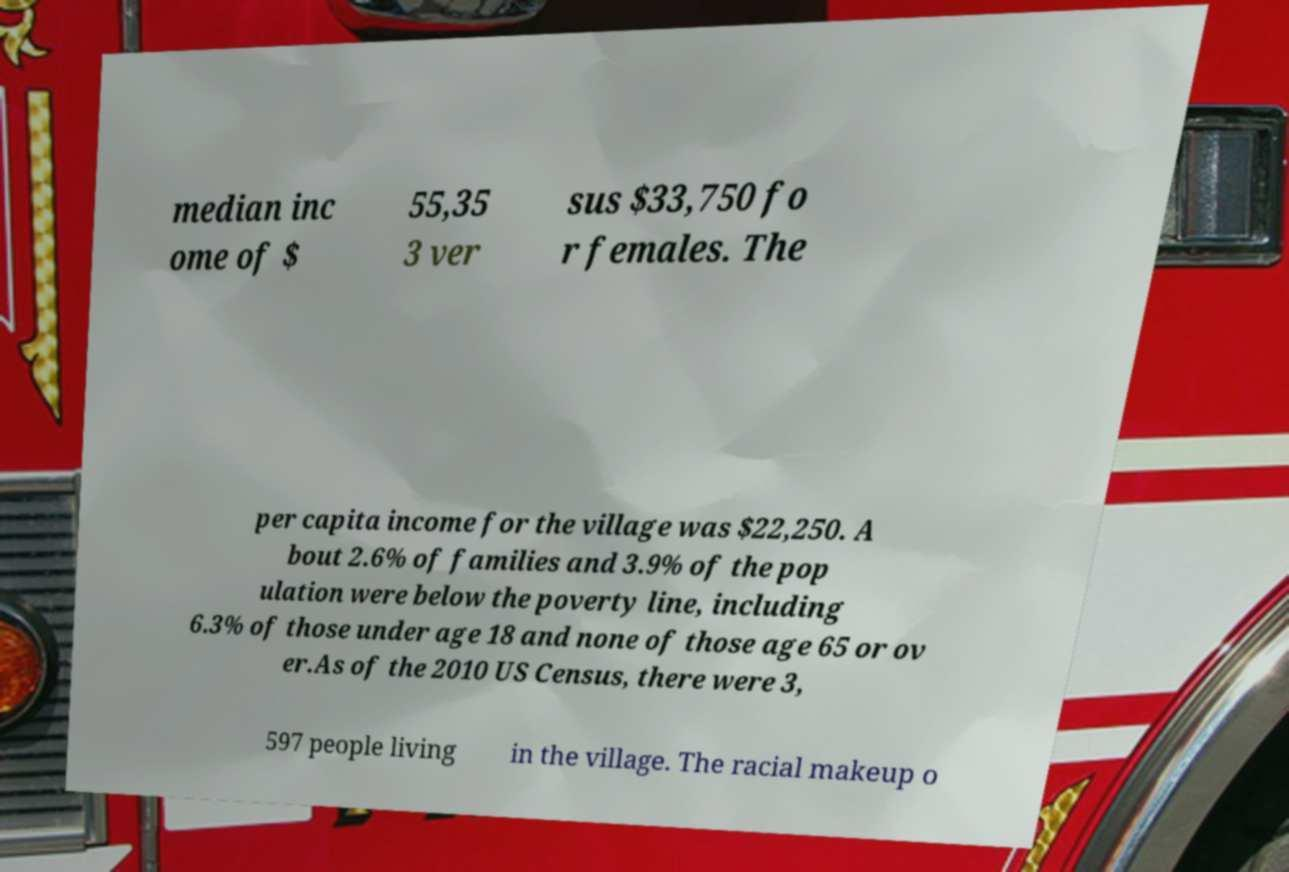Can you read and provide the text displayed in the image?This photo seems to have some interesting text. Can you extract and type it out for me? median inc ome of $ 55,35 3 ver sus $33,750 fo r females. The per capita income for the village was $22,250. A bout 2.6% of families and 3.9% of the pop ulation were below the poverty line, including 6.3% of those under age 18 and none of those age 65 or ov er.As of the 2010 US Census, there were 3, 597 people living in the village. The racial makeup o 